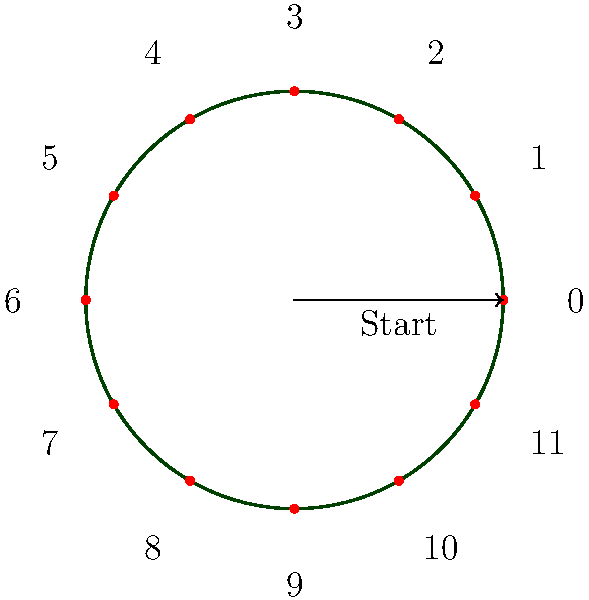Consider the vinyl record groove represented by the circular diagram. If we treat the 12 equally spaced points as elements of a cyclic group $C_{12}$, and each clockwise step represents the group operation, what element would you reach after applying the operation 17 times starting from the element 0? To solve this problem, we can follow these steps:

1) In a cyclic group $C_{12}$, the elements are $\{0, 1, 2, ..., 11\}$, and the group operation is addition modulo 12.

2) We start at element 0 and apply the operation 17 times. This is equivalent to adding 17 to 0 in modulo 12 arithmetic.

3) To calculate this, we can use the formula:
   $$(0 + 17) \bmod 12$$

4) First, let's divide 17 by 12:
   $$17 = 1 \times 12 + 5$$

5) Therefore, $(0 + 17) \bmod 12 = (0 + 5) \bmod 12 = 5$

6) We can verify this geometrically: starting from 0 and moving 17 steps clockwise brings us to the same position as moving 5 steps clockwise.

This result reflects the cyclic nature of vinyl record grooves, where after one full rotation (12 steps), we return to the starting point but on an inner groove.
Answer: 5 